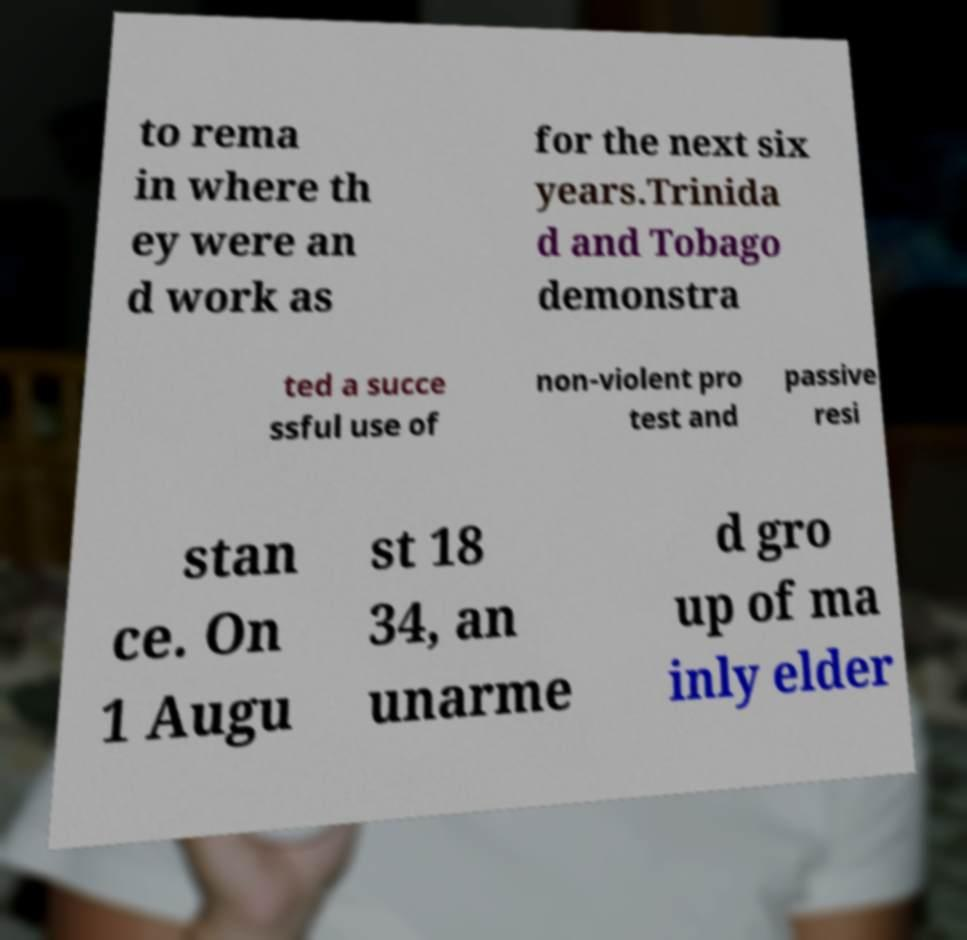Can you read and provide the text displayed in the image?This photo seems to have some interesting text. Can you extract and type it out for me? to rema in where th ey were an d work as for the next six years.Trinida d and Tobago demonstra ted a succe ssful use of non-violent pro test and passive resi stan ce. On 1 Augu st 18 34, an unarme d gro up of ma inly elder 